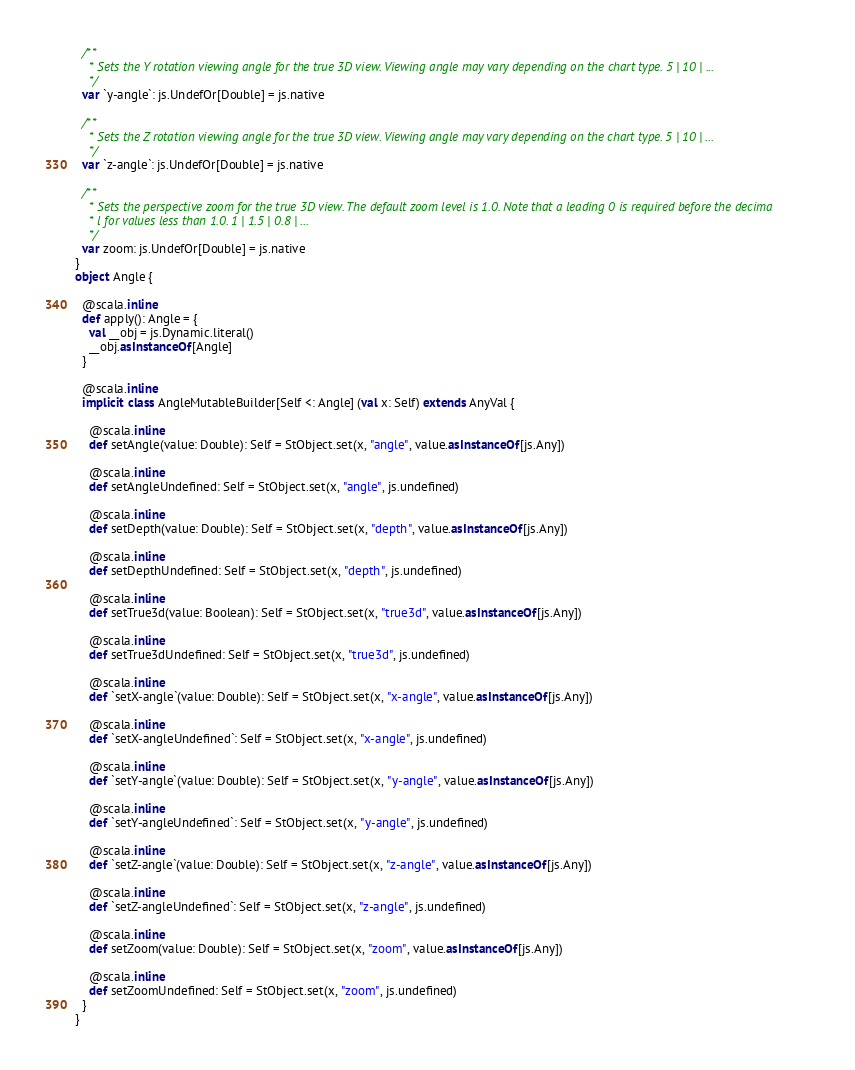<code> <loc_0><loc_0><loc_500><loc_500><_Scala_>  /**
    * Sets the Y rotation viewing angle for the true 3D view. Viewing angle may vary depending on the chart type. 5 | 10 | ...
    */
  var `y-angle`: js.UndefOr[Double] = js.native
  
  /**
    * Sets the Z rotation viewing angle for the true 3D view. Viewing angle may vary depending on the chart type. 5 | 10 | ...
    */
  var `z-angle`: js.UndefOr[Double] = js.native
  
  /**
    * Sets the perspective zoom for the true 3D view. The default zoom level is 1.0. Note that a leading 0 is required before the decima
    * l for values less than 1.0. 1 | 1.5 | 0.8 | ...
    */
  var zoom: js.UndefOr[Double] = js.native
}
object Angle {
  
  @scala.inline
  def apply(): Angle = {
    val __obj = js.Dynamic.literal()
    __obj.asInstanceOf[Angle]
  }
  
  @scala.inline
  implicit class AngleMutableBuilder[Self <: Angle] (val x: Self) extends AnyVal {
    
    @scala.inline
    def setAngle(value: Double): Self = StObject.set(x, "angle", value.asInstanceOf[js.Any])
    
    @scala.inline
    def setAngleUndefined: Self = StObject.set(x, "angle", js.undefined)
    
    @scala.inline
    def setDepth(value: Double): Self = StObject.set(x, "depth", value.asInstanceOf[js.Any])
    
    @scala.inline
    def setDepthUndefined: Self = StObject.set(x, "depth", js.undefined)
    
    @scala.inline
    def setTrue3d(value: Boolean): Self = StObject.set(x, "true3d", value.asInstanceOf[js.Any])
    
    @scala.inline
    def setTrue3dUndefined: Self = StObject.set(x, "true3d", js.undefined)
    
    @scala.inline
    def `setX-angle`(value: Double): Self = StObject.set(x, "x-angle", value.asInstanceOf[js.Any])
    
    @scala.inline
    def `setX-angleUndefined`: Self = StObject.set(x, "x-angle", js.undefined)
    
    @scala.inline
    def `setY-angle`(value: Double): Self = StObject.set(x, "y-angle", value.asInstanceOf[js.Any])
    
    @scala.inline
    def `setY-angleUndefined`: Self = StObject.set(x, "y-angle", js.undefined)
    
    @scala.inline
    def `setZ-angle`(value: Double): Self = StObject.set(x, "z-angle", value.asInstanceOf[js.Any])
    
    @scala.inline
    def `setZ-angleUndefined`: Self = StObject.set(x, "z-angle", js.undefined)
    
    @scala.inline
    def setZoom(value: Double): Self = StObject.set(x, "zoom", value.asInstanceOf[js.Any])
    
    @scala.inline
    def setZoomUndefined: Self = StObject.set(x, "zoom", js.undefined)
  }
}
</code> 